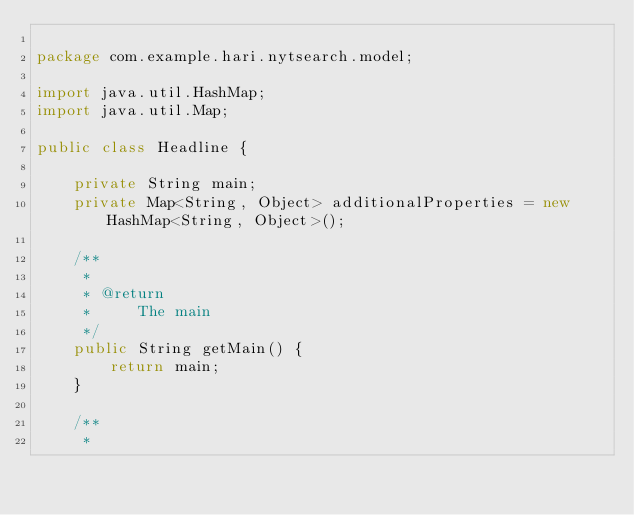<code> <loc_0><loc_0><loc_500><loc_500><_Java_>
package com.example.hari.nytsearch.model;

import java.util.HashMap;
import java.util.Map;

public class Headline {

    private String main;
    private Map<String, Object> additionalProperties = new HashMap<String, Object>();

    /**
     * 
     * @return
     *     The main
     */
    public String getMain() {
        return main;
    }

    /**
     * </code> 